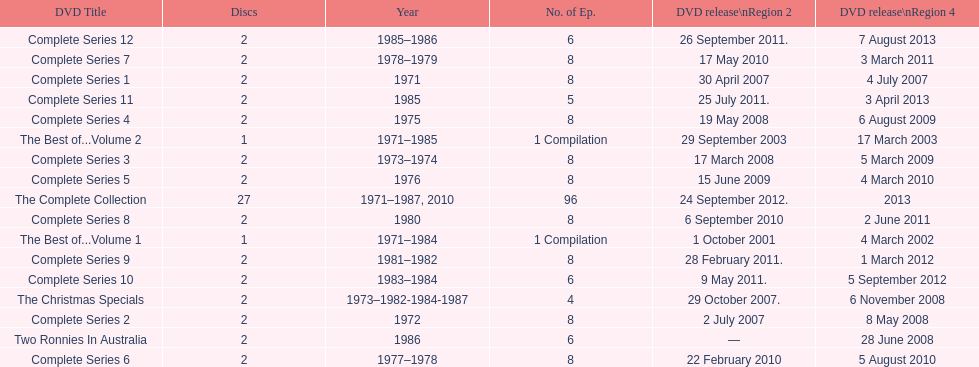Could you help me parse every detail presented in this table? {'header': ['DVD Title', 'Discs', 'Year', 'No. of Ep.', 'DVD release\\nRegion 2', 'DVD release\\nRegion 4'], 'rows': [['Complete Series 12', '2', '1985–1986', '6', '26 September 2011.', '7 August 2013'], ['Complete Series 7', '2', '1978–1979', '8', '17 May 2010', '3 March 2011'], ['Complete Series 1', '2', '1971', '8', '30 April 2007', '4 July 2007'], ['Complete Series 11', '2', '1985', '5', '25 July 2011.', '3 April 2013'], ['Complete Series 4', '2', '1975', '8', '19 May 2008', '6 August 2009'], ['The Best of...Volume 2', '1', '1971–1985', '1 Compilation', '29 September 2003', '17 March 2003'], ['Complete Series 3', '2', '1973–1974', '8', '17 March 2008', '5 March 2009'], ['Complete Series 5', '2', '1976', '8', '15 June 2009', '4 March 2010'], ['The Complete Collection', '27', '1971–1987, 2010', '96', '24 September 2012.', '2013'], ['Complete Series 8', '2', '1980', '8', '6 September 2010', '2 June 2011'], ['The Best of...Volume 1', '1', '1971–1984', '1 Compilation', '1 October 2001', '4 March 2002'], ['Complete Series 9', '2', '1981–1982', '8', '28 February 2011.', '1 March 2012'], ['Complete Series 10', '2', '1983–1984', '6', '9 May 2011.', '5 September 2012'], ['The Christmas Specials', '2', '1973–1982-1984-1987', '4', '29 October 2007.', '6 November 2008'], ['Complete Series 2', '2', '1972', '8', '2 July 2007', '8 May 2008'], ['Two Ronnies In Australia', '2', '1986', '6', '—', '28 June 2008'], ['Complete Series 6', '2', '1977–1978', '8', '22 February 2010', '5 August 2010']]} The television show "the two ronnies" ran for a total of how many seasons? 12. 